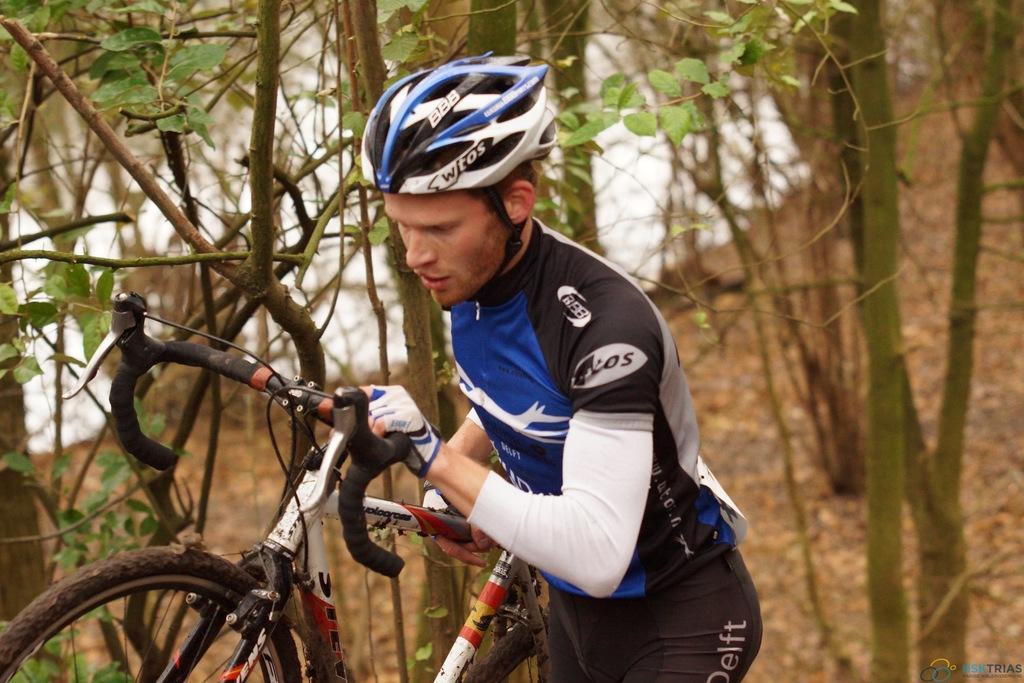Who is present in the image? There is a man in the image. What is the man holding in the image? The man is holding a bicycle. What type of vegetation can be seen in the image? There are trees on the ground in the image. What can be seen in the background of the image? There is water visible in the background of the image. What type of leather is used to make the reward in the image? There is no reward or leather present in the image. What type of trail can be seen in the image? There is no trail visible in the image. 